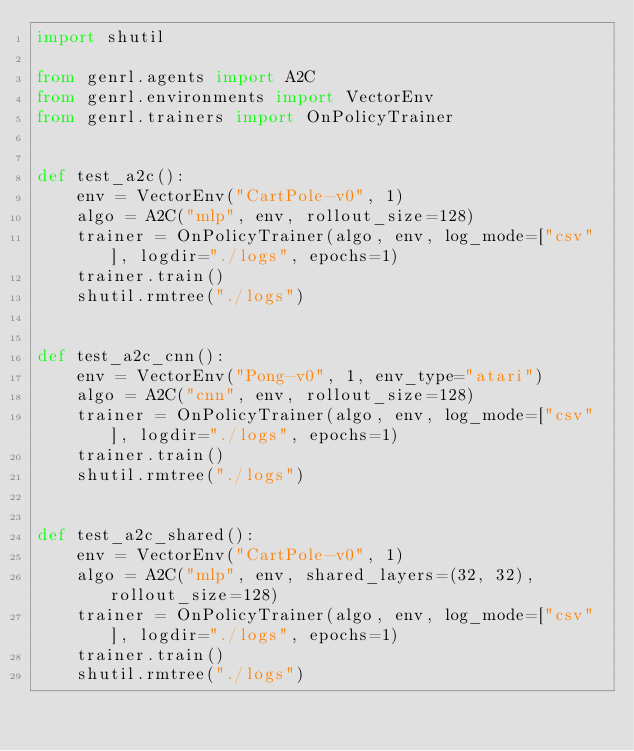<code> <loc_0><loc_0><loc_500><loc_500><_Python_>import shutil

from genrl.agents import A2C
from genrl.environments import VectorEnv
from genrl.trainers import OnPolicyTrainer


def test_a2c():
    env = VectorEnv("CartPole-v0", 1)
    algo = A2C("mlp", env, rollout_size=128)
    trainer = OnPolicyTrainer(algo, env, log_mode=["csv"], logdir="./logs", epochs=1)
    trainer.train()
    shutil.rmtree("./logs")


def test_a2c_cnn():
    env = VectorEnv("Pong-v0", 1, env_type="atari")
    algo = A2C("cnn", env, rollout_size=128)
    trainer = OnPolicyTrainer(algo, env, log_mode=["csv"], logdir="./logs", epochs=1)
    trainer.train()
    shutil.rmtree("./logs")


def test_a2c_shared():
    env = VectorEnv("CartPole-v0", 1)
    algo = A2C("mlp", env, shared_layers=(32, 32), rollout_size=128)
    trainer = OnPolicyTrainer(algo, env, log_mode=["csv"], logdir="./logs", epochs=1)
    trainer.train()
    shutil.rmtree("./logs")
</code> 